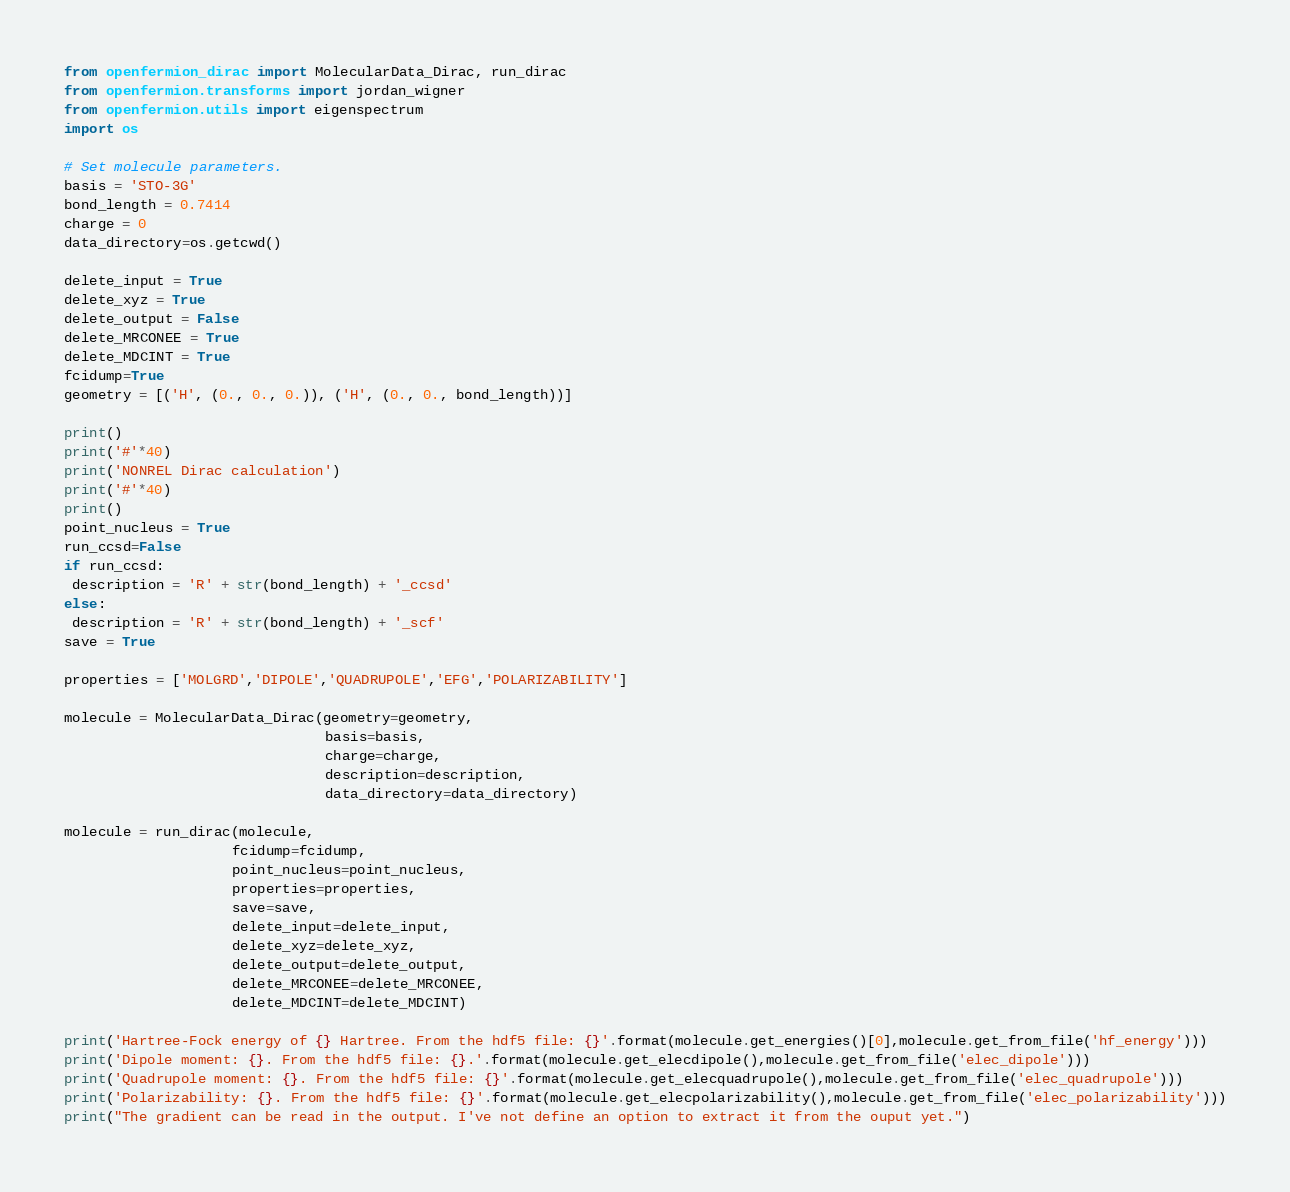Convert code to text. <code><loc_0><loc_0><loc_500><loc_500><_Python_>from openfermion_dirac import MolecularData_Dirac, run_dirac
from openfermion.transforms import jordan_wigner
from openfermion.utils import eigenspectrum
import os

# Set molecule parameters.
basis = 'STO-3G'
bond_length = 0.7414
charge = 0
data_directory=os.getcwd()

delete_input = True
delete_xyz = True
delete_output = False
delete_MRCONEE = True
delete_MDCINT = True
fcidump=True
geometry = [('H', (0., 0., 0.)), ('H', (0., 0., bond_length))]

print()
print('#'*40)
print('NONREL Dirac calculation')
print('#'*40)
print()
point_nucleus = True
run_ccsd=False
if run_ccsd:
 description = 'R' + str(bond_length) + '_ccsd'
else:
 description = 'R' + str(bond_length) + '_scf'
save = True

properties = ['MOLGRD','DIPOLE','QUADRUPOLE','EFG','POLARIZABILITY']

molecule = MolecularData_Dirac(geometry=geometry,
                               basis=basis,
                               charge=charge,
                               description=description,
                               data_directory=data_directory)

molecule = run_dirac(molecule,
                    fcidump=fcidump,
                    point_nucleus=point_nucleus,
                    properties=properties,
                    save=save,
                    delete_input=delete_input,
                    delete_xyz=delete_xyz,
                    delete_output=delete_output,
                    delete_MRCONEE=delete_MRCONEE,
                    delete_MDCINT=delete_MDCINT)

print('Hartree-Fock energy of {} Hartree. From the hdf5 file: {}'.format(molecule.get_energies()[0],molecule.get_from_file('hf_energy')))
print('Dipole moment: {}. From the hdf5 file: {}.'.format(molecule.get_elecdipole(),molecule.get_from_file('elec_dipole')))
print('Quadrupole moment: {}. From the hdf5 file: {}'.format(molecule.get_elecquadrupole(),molecule.get_from_file('elec_quadrupole')))
print('Polarizability: {}. From the hdf5 file: {}'.format(molecule.get_elecpolarizability(),molecule.get_from_file('elec_polarizability')))
print("The gradient can be read in the output. I've not define an option to extract it from the ouput yet.")
</code> 